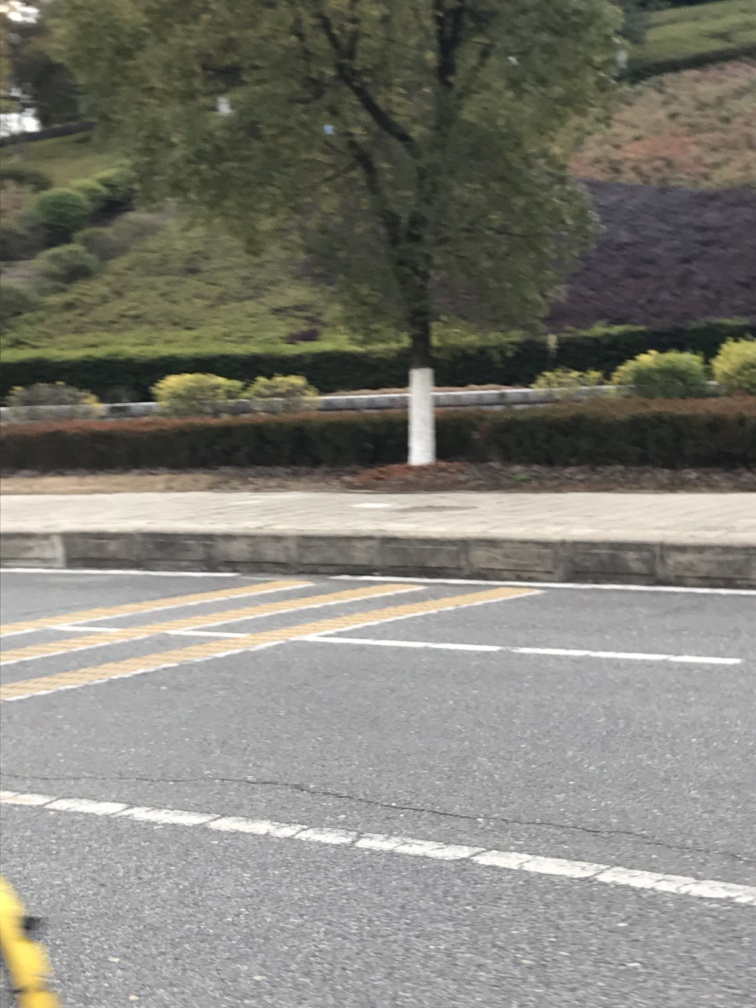Does the image have noticeable motion blur? Indeed, the image exhibits a clear case of motion blur, particularly noticeable on the street and immediate surroundings, which suggests that the photo was taken while in motion, possibly from a moving vehicle. 